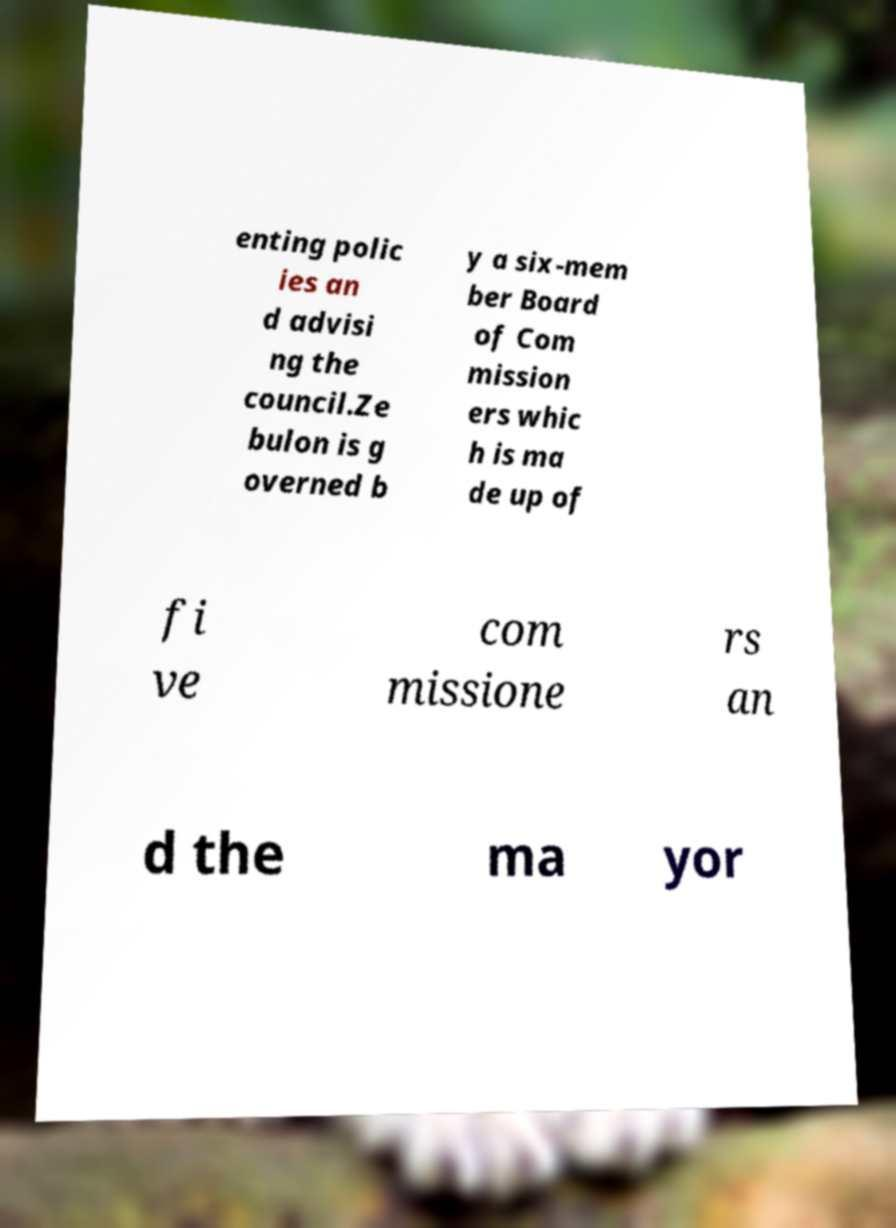What messages or text are displayed in this image? I need them in a readable, typed format. enting polic ies an d advisi ng the council.Ze bulon is g overned b y a six-mem ber Board of Com mission ers whic h is ma de up of fi ve com missione rs an d the ma yor 